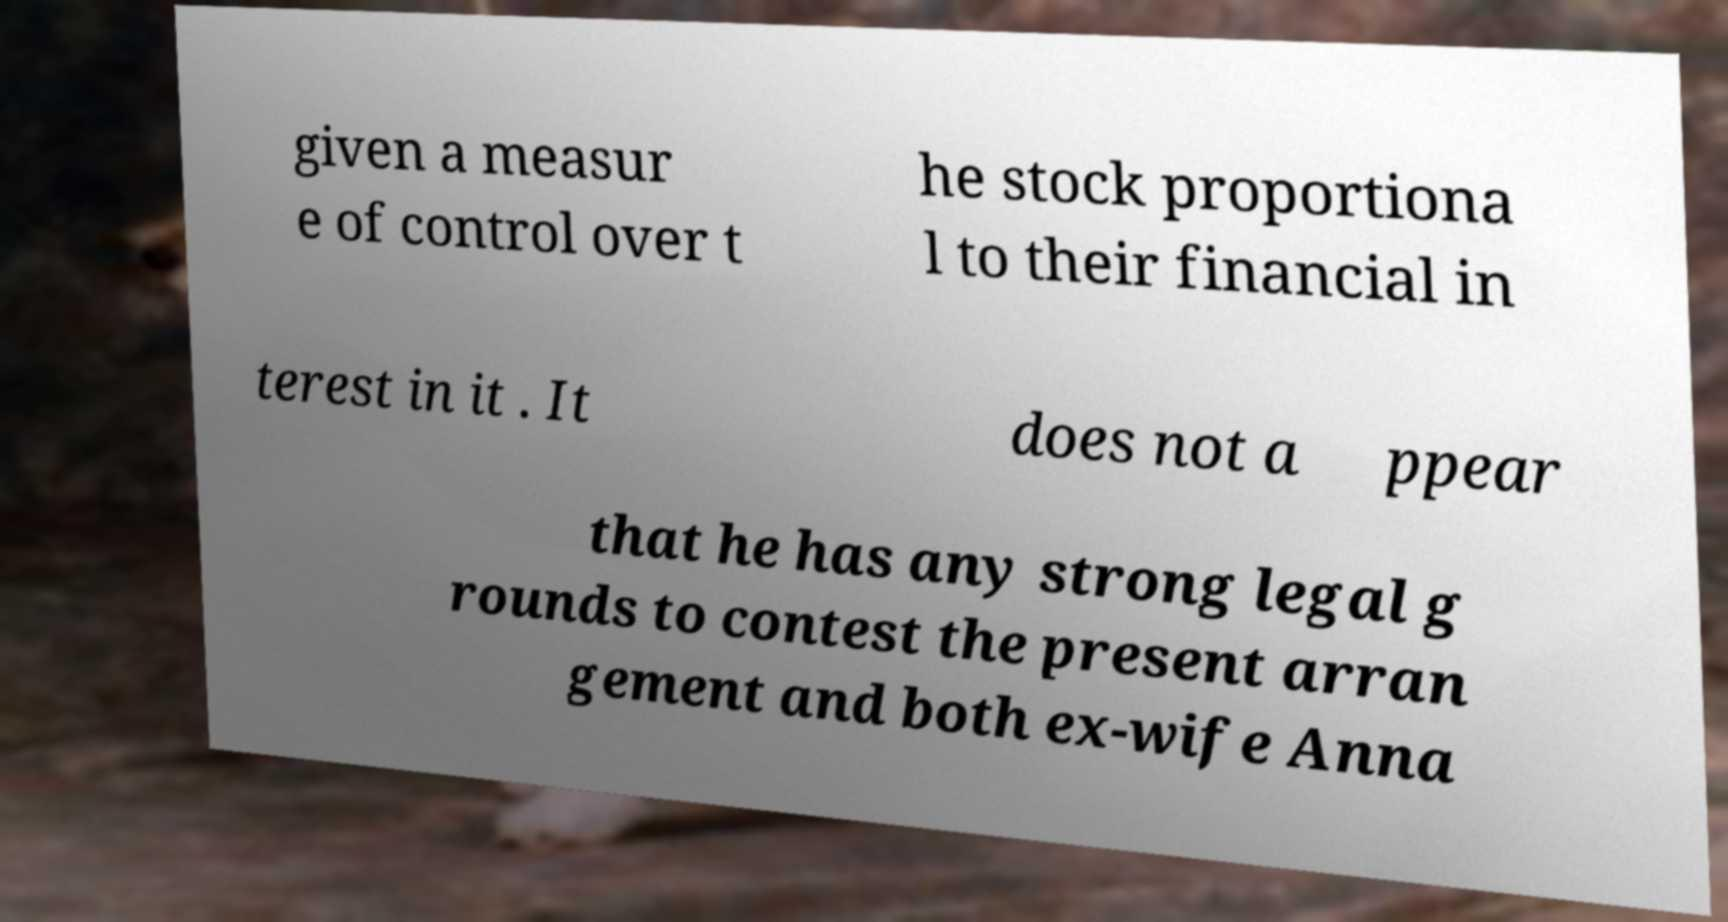Can you read and provide the text displayed in the image?This photo seems to have some interesting text. Can you extract and type it out for me? given a measur e of control over t he stock proportiona l to their financial in terest in it . It does not a ppear that he has any strong legal g rounds to contest the present arran gement and both ex-wife Anna 